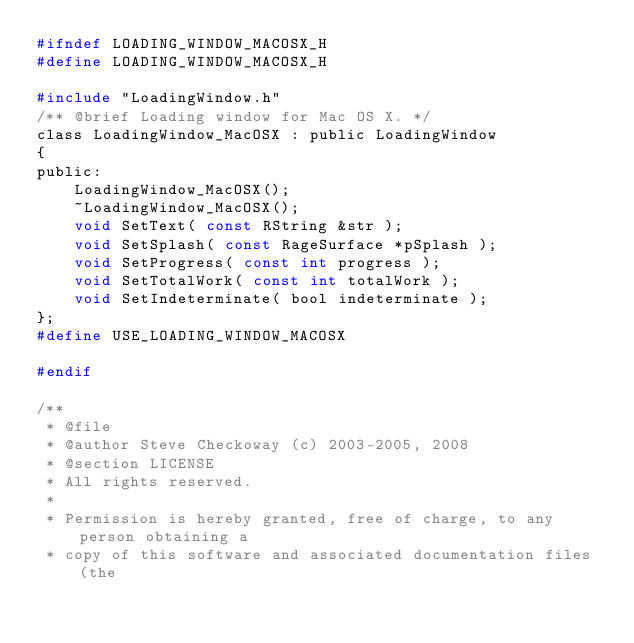Convert code to text. <code><loc_0><loc_0><loc_500><loc_500><_C_>#ifndef LOADING_WINDOW_MACOSX_H
#define LOADING_WINDOW_MACOSX_H

#include "LoadingWindow.h"
/** @brief Loading window for Mac OS X. */
class LoadingWindow_MacOSX : public LoadingWindow
{
public:
	LoadingWindow_MacOSX();
	~LoadingWindow_MacOSX();
	void SetText( const RString &str );
	void SetSplash( const RageSurface *pSplash );
	void SetProgress( const int progress );
	void SetTotalWork( const int totalWork );
	void SetIndeterminate( bool indeterminate );
};
#define USE_LOADING_WINDOW_MACOSX

#endif

/**
 * @file
 * @author Steve Checkoway (c) 2003-2005, 2008
 * @section LICENSE
 * All rights reserved.
 *
 * Permission is hereby granted, free of charge, to any person obtaining a
 * copy of this software and associated documentation files (the</code> 